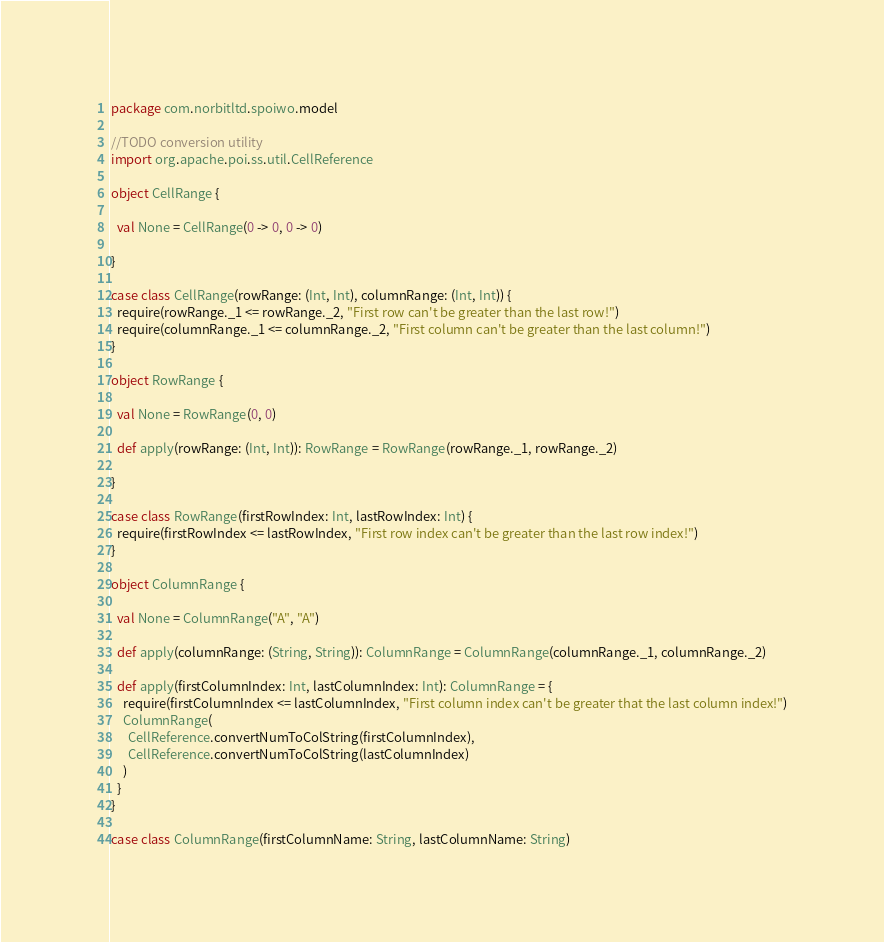<code> <loc_0><loc_0><loc_500><loc_500><_Scala_>package com.norbitltd.spoiwo.model

//TODO conversion utility
import org.apache.poi.ss.util.CellReference

object CellRange {

  val None = CellRange(0 -> 0, 0 -> 0)

}

case class CellRange(rowRange: (Int, Int), columnRange: (Int, Int)) {
  require(rowRange._1 <= rowRange._2, "First row can't be greater than the last row!")
  require(columnRange._1 <= columnRange._2, "First column can't be greater than the last column!")
}

object RowRange {

  val None = RowRange(0, 0)

  def apply(rowRange: (Int, Int)): RowRange = RowRange(rowRange._1, rowRange._2)

}

case class RowRange(firstRowIndex: Int, lastRowIndex: Int) {
  require(firstRowIndex <= lastRowIndex, "First row index can't be greater than the last row index!")
}

object ColumnRange {

  val None = ColumnRange("A", "A")

  def apply(columnRange: (String, String)): ColumnRange = ColumnRange(columnRange._1, columnRange._2)

  def apply(firstColumnIndex: Int, lastColumnIndex: Int): ColumnRange = {
    require(firstColumnIndex <= lastColumnIndex, "First column index can't be greater that the last column index!")
    ColumnRange(
      CellReference.convertNumToColString(firstColumnIndex),
      CellReference.convertNumToColString(lastColumnIndex)
    )
  }
}

case class ColumnRange(firstColumnName: String, lastColumnName: String)
</code> 